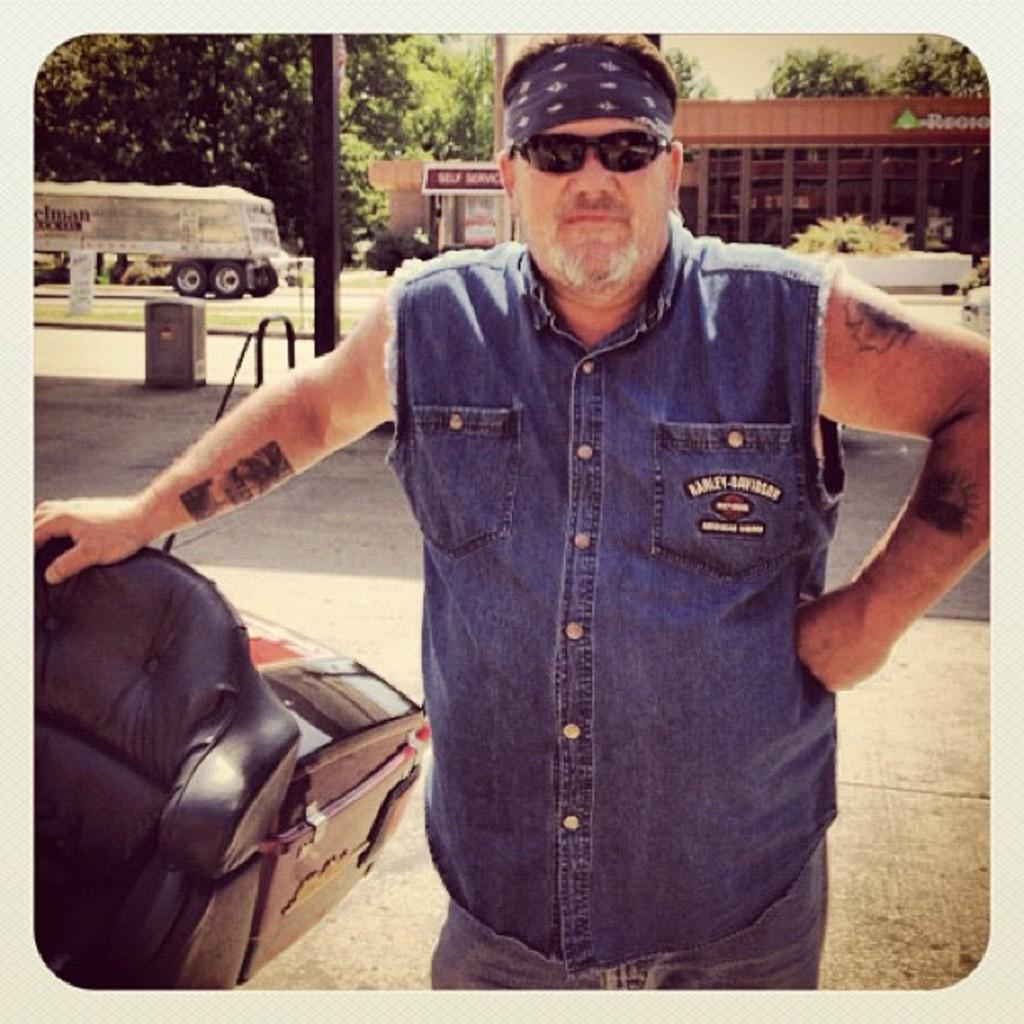What is the person in the image wearing on their face? The person is wearing goggles in the image. What else is the person wearing on their head? The person is also wearing a headband in the image. What can be seen in the background of the image? There are poles, trees, buildings, and the sky visible in the background of the image. How many books are stacked on the bell in the image? There are no books or bells present in the image. What type of adjustment is being made to the person's headband in the image? There is no adjustment being made to the person's headband in the image; it appears to be securely in place. 